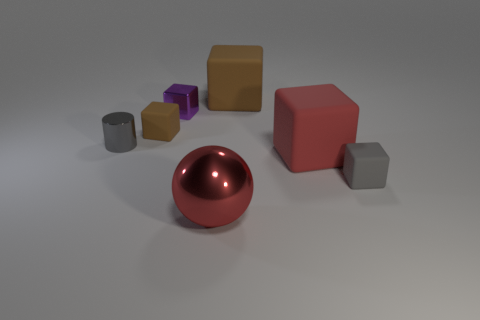Subtract all purple metallic blocks. How many blocks are left? 4 Subtract all blue cylinders. How many brown blocks are left? 2 Add 2 big rubber cubes. How many objects exist? 9 Subtract all gray blocks. How many blocks are left? 4 Subtract 1 cubes. How many cubes are left? 4 Add 6 gray cylinders. How many gray cylinders exist? 7 Subtract 0 green blocks. How many objects are left? 7 Subtract all balls. How many objects are left? 6 Subtract all purple blocks. Subtract all red balls. How many blocks are left? 4 Subtract all small purple balls. Subtract all big brown cubes. How many objects are left? 6 